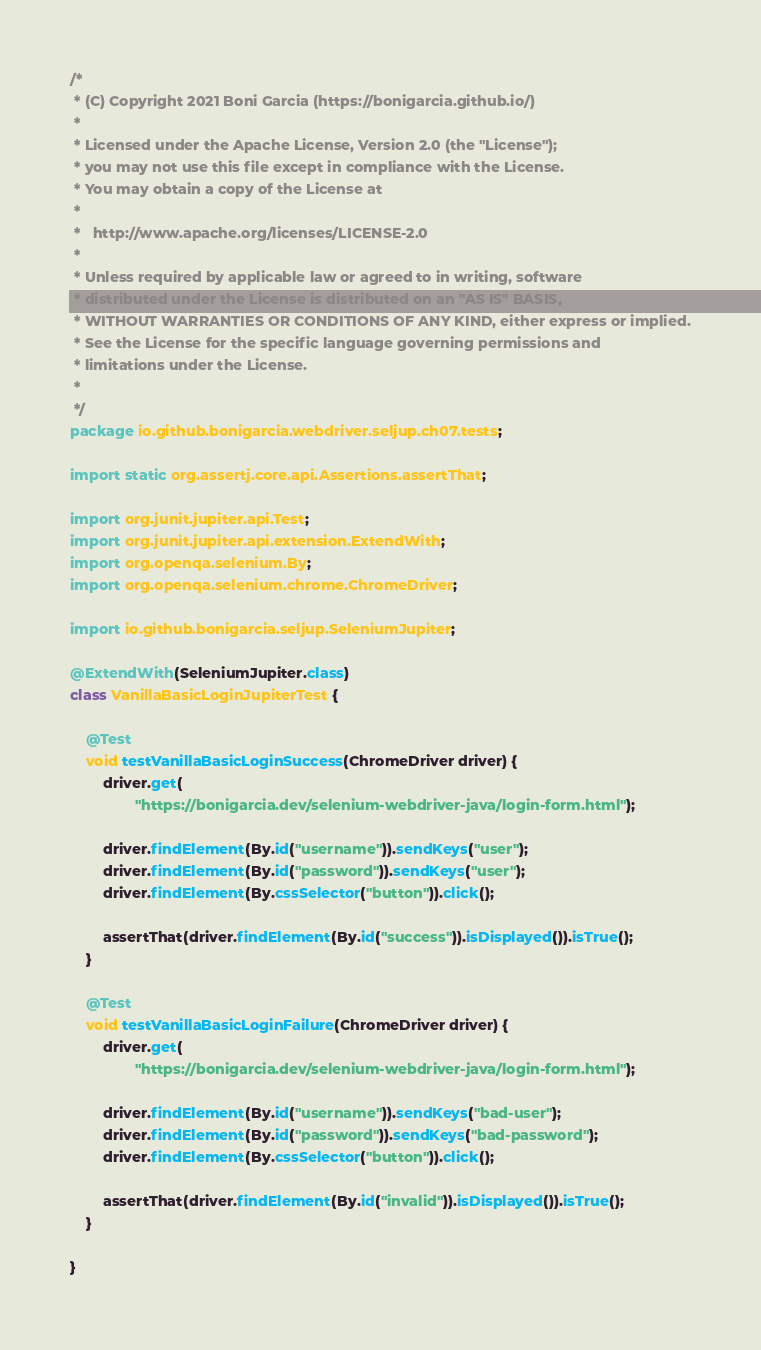<code> <loc_0><loc_0><loc_500><loc_500><_Java_>/*
 * (C) Copyright 2021 Boni Garcia (https://bonigarcia.github.io/)
 *
 * Licensed under the Apache License, Version 2.0 (the "License");
 * you may not use this file except in compliance with the License.
 * You may obtain a copy of the License at
 *
 *   http://www.apache.org/licenses/LICENSE-2.0
 *
 * Unless required by applicable law or agreed to in writing, software
 * distributed under the License is distributed on an "AS IS" BASIS,
 * WITHOUT WARRANTIES OR CONDITIONS OF ANY KIND, either express or implied.
 * See the License for the specific language governing permissions and
 * limitations under the License.
 *
 */
package io.github.bonigarcia.webdriver.seljup.ch07.tests;

import static org.assertj.core.api.Assertions.assertThat;

import org.junit.jupiter.api.Test;
import org.junit.jupiter.api.extension.ExtendWith;
import org.openqa.selenium.By;
import org.openqa.selenium.chrome.ChromeDriver;

import io.github.bonigarcia.seljup.SeleniumJupiter;

@ExtendWith(SeleniumJupiter.class)
class VanillaBasicLoginJupiterTest {

    @Test
    void testVanillaBasicLoginSuccess(ChromeDriver driver) {
        driver.get(
                "https://bonigarcia.dev/selenium-webdriver-java/login-form.html");

        driver.findElement(By.id("username")).sendKeys("user");
        driver.findElement(By.id("password")).sendKeys("user");
        driver.findElement(By.cssSelector("button")).click();

        assertThat(driver.findElement(By.id("success")).isDisplayed()).isTrue();
    }

    @Test
    void testVanillaBasicLoginFailure(ChromeDriver driver) {
        driver.get(
                "https://bonigarcia.dev/selenium-webdriver-java/login-form.html");

        driver.findElement(By.id("username")).sendKeys("bad-user");
        driver.findElement(By.id("password")).sendKeys("bad-password");
        driver.findElement(By.cssSelector("button")).click();

        assertThat(driver.findElement(By.id("invalid")).isDisplayed()).isTrue();
    }

}
</code> 